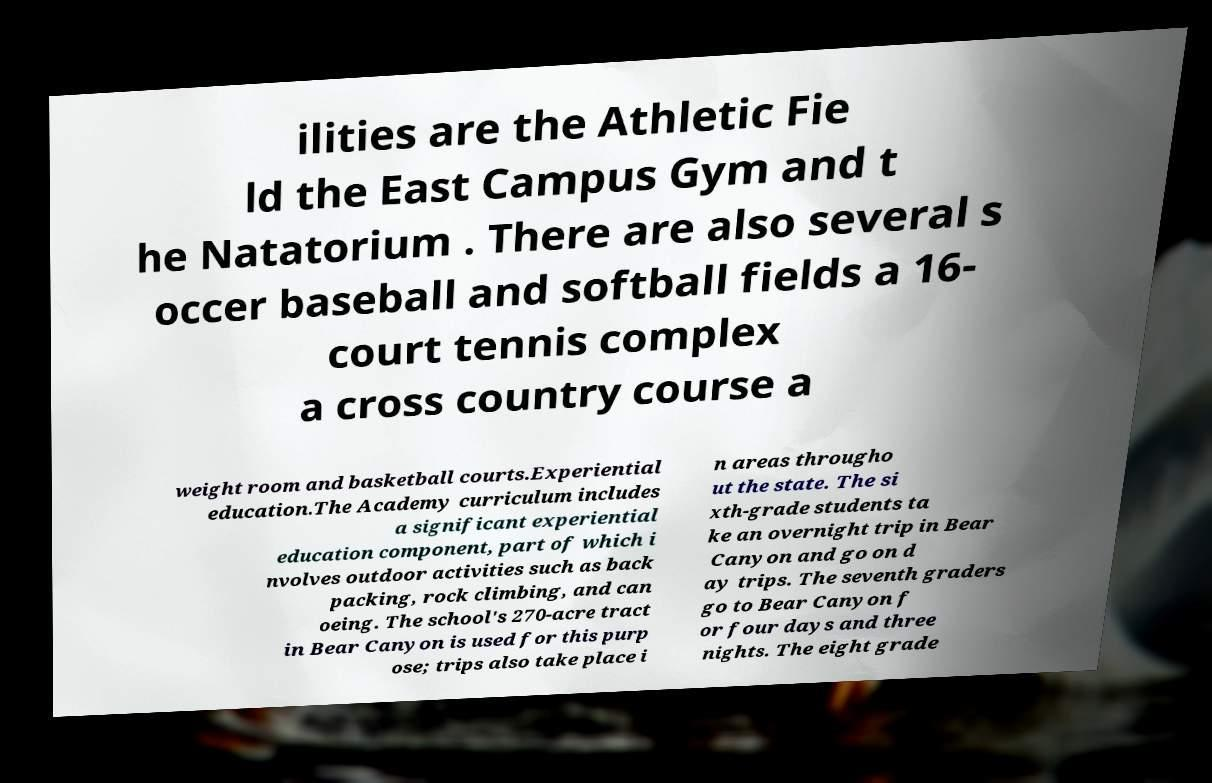Please read and relay the text visible in this image. What does it say? ilities are the Athletic Fie ld the East Campus Gym and t he Natatorium . There are also several s occer baseball and softball fields a 16- court tennis complex a cross country course a weight room and basketball courts.Experiential education.The Academy curriculum includes a significant experiential education component, part of which i nvolves outdoor activities such as back packing, rock climbing, and can oeing. The school's 270-acre tract in Bear Canyon is used for this purp ose; trips also take place i n areas througho ut the state. The si xth-grade students ta ke an overnight trip in Bear Canyon and go on d ay trips. The seventh graders go to Bear Canyon f or four days and three nights. The eight grade 